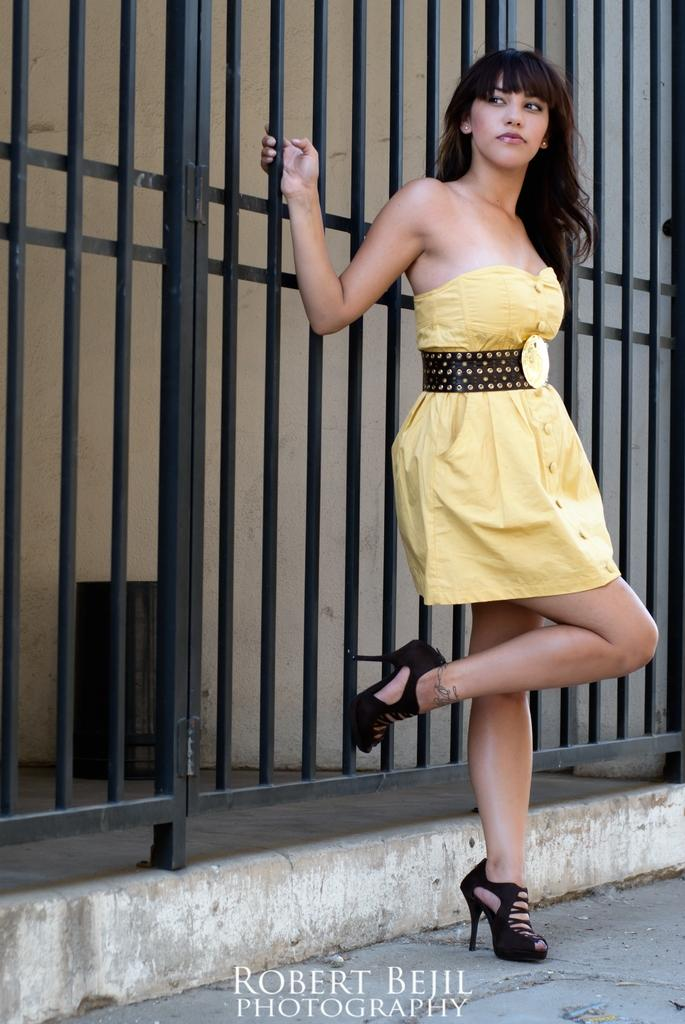Who is present in the image? There is a woman in the image. What is the woman wearing? The woman is wearing a yellow dress. What is the woman doing in the image? The woman is standing. What object can be seen in the image besides the woman? There is a black grill in the image. Is there any additional information about the image itself? Yes, there is a watermark in the image. How many rings does the woman have on her fingers in the image? There is no information about rings on the woman's fingers in the image, as the provided facts do not mention any jewelry. 